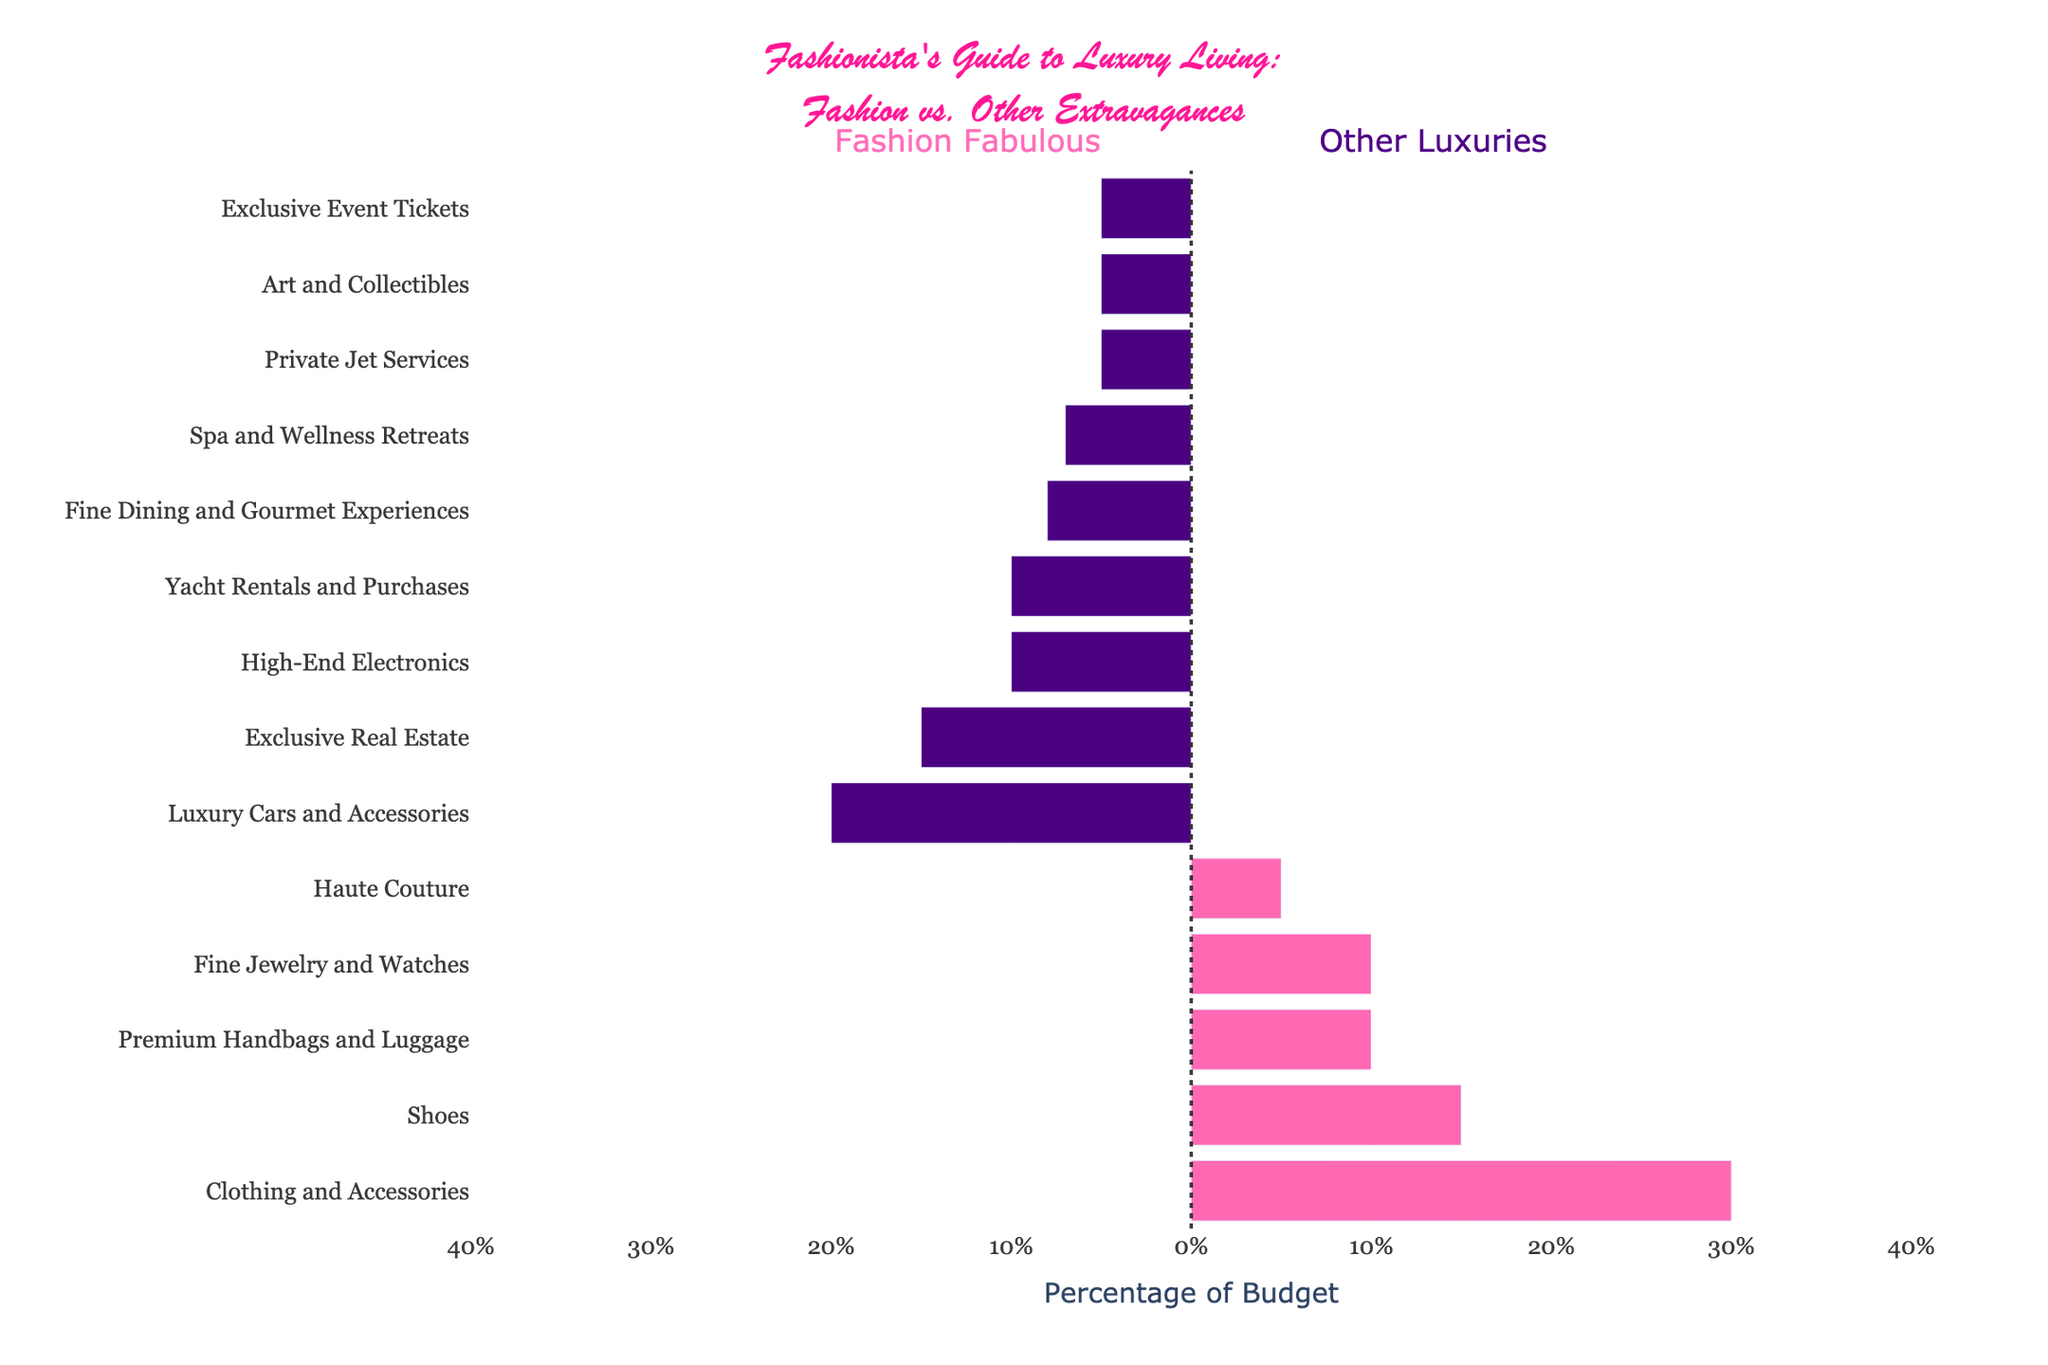What's the total percentage allocated to Fashion? Add all percentages in the fashion category: 30% (Clothing and Accessories) + 15% (Shoes) + 10% (Premium Handbags and Luggage) + 10% (Fine Jewelry and Watches) + 5% (Haute Couture) = 70%
Answer: 70% Which category has the highest percentage in Other Luxury Expenses, and how much is it? Look at the bars under "Other Luxury Expenses" and identify the longest one, which is "Luxury Cars and Accessories" with a percentage of 20%
Answer: Luxury Cars and Accessories, 20% How does the percentage for Private Jet Services compare to Haute Couture? Compare the bar lengths for "Private Jet Services" (Other Luxury Expenses) and "Haute Couture" (Fashion). Both categories have a bar length corresponding to 5%
Answer: They are equal, both are 5% What's the combined percentage for Exclusive Real Estate and High-End Electronics? Add the percentages for those categories: 15% (Exclusive Real Estate) + 10% (High-End Electronics) = 25%
Answer: 25% Which has a higher allocation, Fine Dining and Gourmet Experiences or Spa and Wellness Retreats, and by how much? Compare the bar lengths of "Fine Dining and Gourmet Experiences" (8%) and "Spa and Wellness Retreats" (7%). The difference is 8% - 7% = 1%
Answer: Fine Dining and Gourmet Experiences by 1% What's the percentage difference between spending on Clothing and Accessories (Fashion) and Luxury Cars and Accessories (Other Luxury Expenses)? Subtract the percentage of "Luxury Cars and Accessories" (20%) from "Clothing and Accessories" (30%): 30% - 20% = 10%
Answer: 10% If you combine the percentages of Premium Handbags and Luggage, Fine Jewelry and Watches from Fashion, and Exclusive Event Tickets from Other Luxury Expenses, what is the total? Add the percentages for the categories: 10% (Premium Handbags and Luggage) + 10% (Fine Jewelry and Watches) + 5% (Exclusive Event Tickets) = 25%
Answer: 25% Which category under Fashion has the smallest allocation? Find the shortest bar in the Fashion category, which is "Haute Couture" with an allocation of 5%
Answer: Haute Couture, 5% Are there more categories under Fashion or Other Luxury Expenses, and by how many? Count the categories in each group. Fashion has 5 categories, and Other Luxury Expenses has 9 categories. The difference is 9 - 5 = 4
Answer: Other Luxury Expenses, by 4 What's the total percentage allocated to Other Luxury Expenses? Sum all percentages in the "Other Luxury Expenses" category: 20% + 15% + 10% + 10% + 5% + 7% + 8% + 5% + 5% = 85%
Answer: 85% 